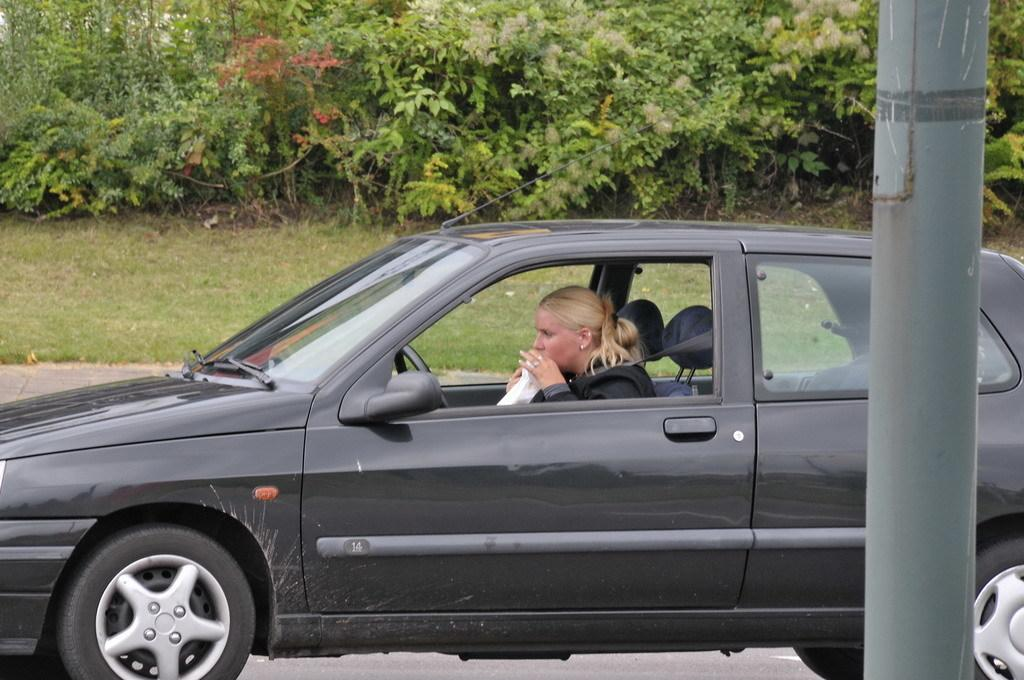What is the woman in the image doing? The woman is sitting in a car in the image. What else can be seen in the image besides the woman and the car? There is a plant on grassy land in the image. What is the woman holding in the image? The woman is holding some cloth in the image. How would you describe the background of the image? The background of the image is very green and likely represents a grassy or natural environment. Can you see any volcanoes in the image? No, there are no volcanoes present in the image. 